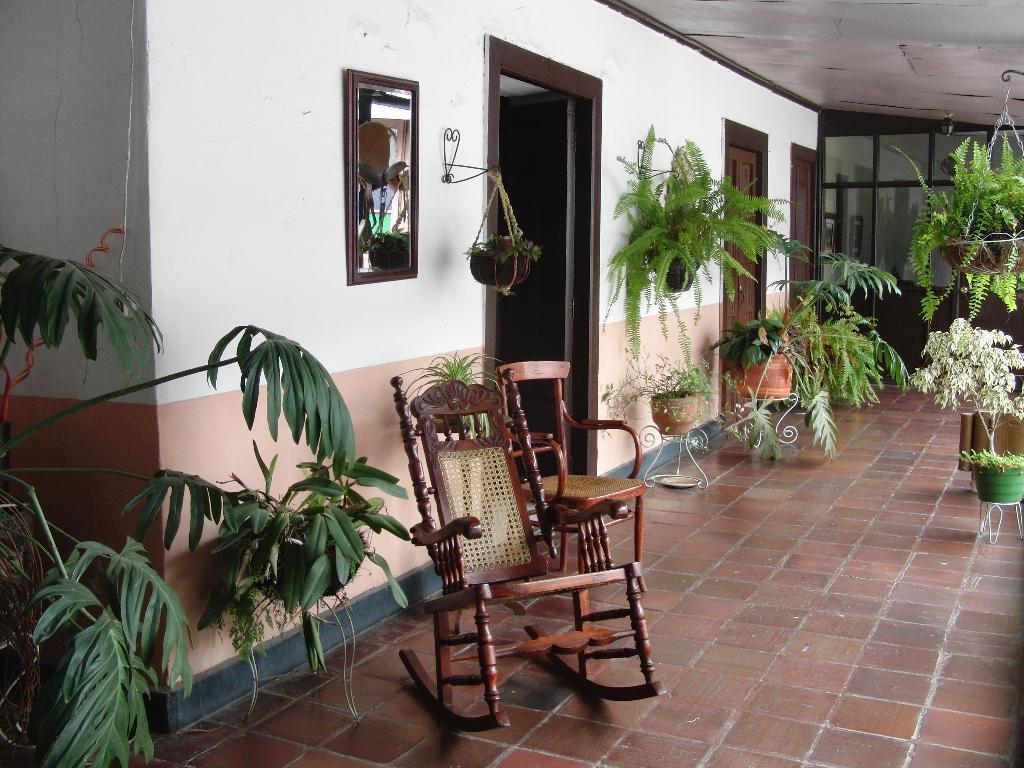How would you summarize this image in a sentence or two? In this image we can see there are two chairs on the floor and a few pots of plants on the ground and some hanging pots of plants. On the wall we can see there is a mirror and three doors. 